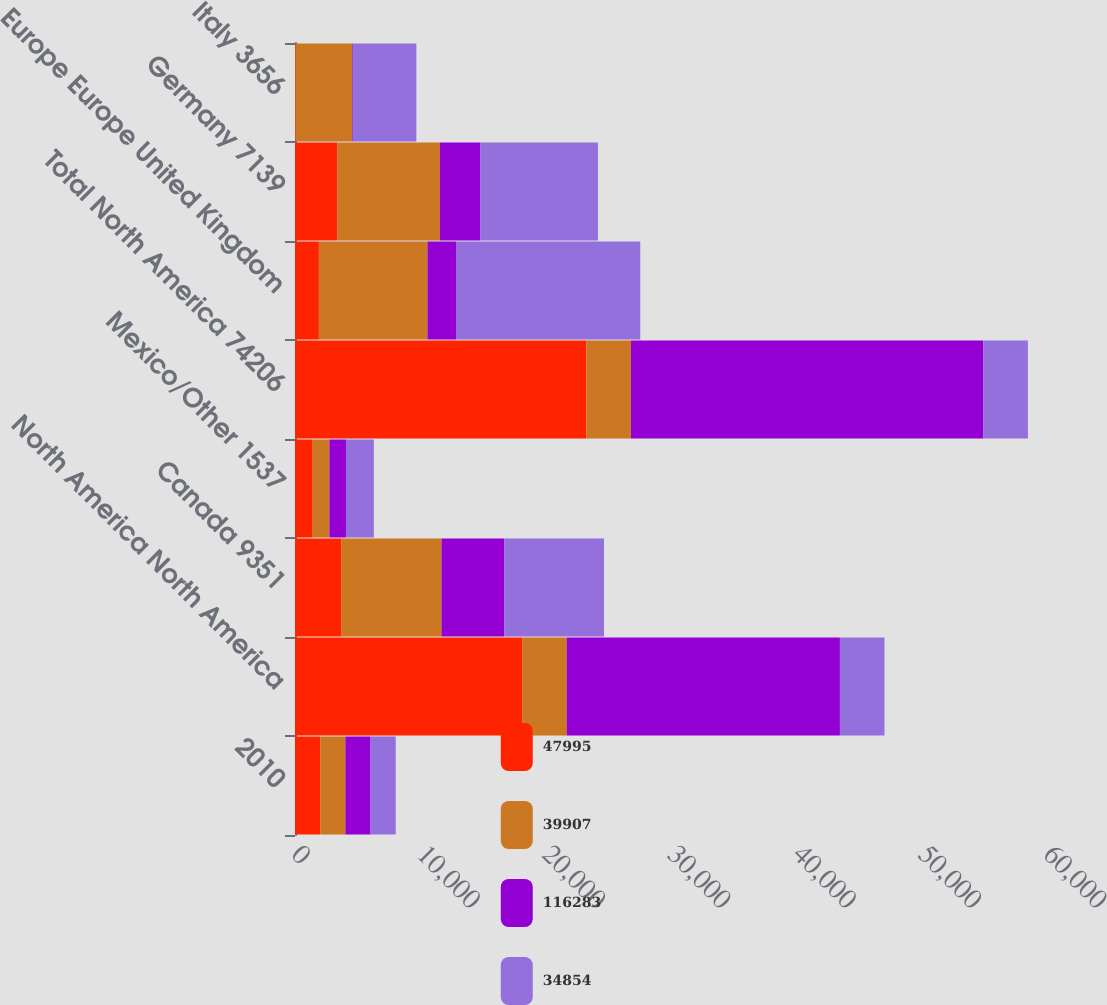<chart> <loc_0><loc_0><loc_500><loc_500><stacked_bar_chart><ecel><fcel>2010<fcel>North America North America<fcel>Canada 9351<fcel>Mexico/Other 1537<fcel>Total North America 74206<fcel>Europe Europe United Kingdom<fcel>Germany 7139<fcel>Italy 3656<nl><fcel>47995<fcel>2010<fcel>18124<fcel>3713<fcel>1410<fcel>23247<fcel>1907<fcel>3395<fcel>48<nl><fcel>39907<fcel>2009<fcel>3554<fcel>7974<fcel>1335<fcel>3554<fcel>8661<fcel>8161<fcel>4529<nl><fcel>116283<fcel>2009<fcel>21800<fcel>5000<fcel>1321<fcel>28121<fcel>2277<fcel>3217<fcel>53<nl><fcel>34854<fcel>2008<fcel>3554<fcel>7964<fcel>2225<fcel>3554<fcel>14702<fcel>9399<fcel>5052<nl></chart> 